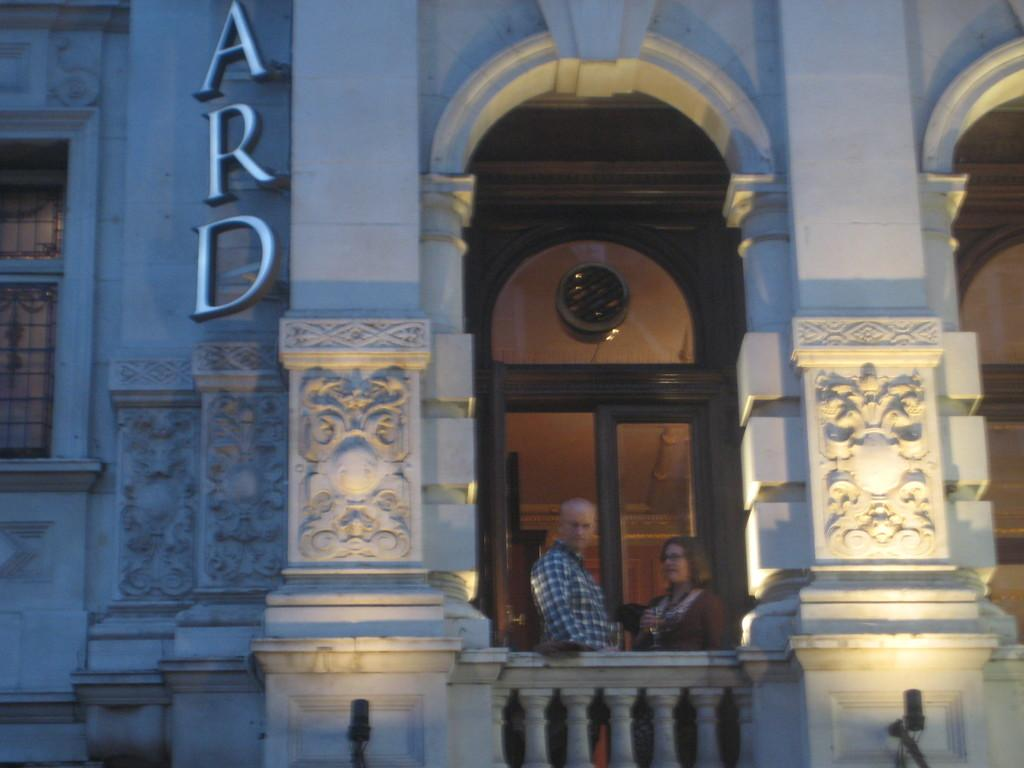How many people are in the image? There are two persons standing in the image. What can be seen in the background of the image? There is a glass door and a white building in the background of the image. What type of rose is being held by the person on the left in the image? There is no rose present in the image; it only features two persons standing and a background with a glass door and a white building. 